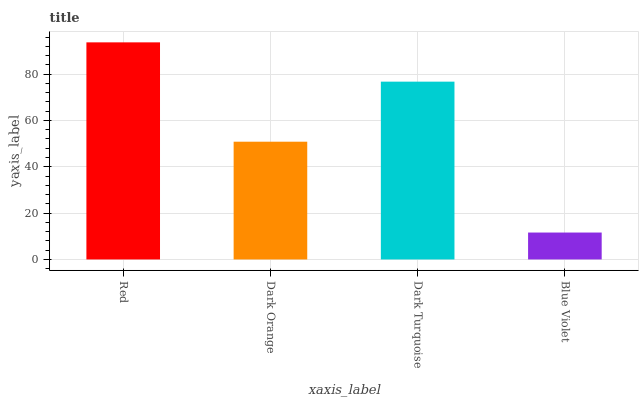Is Blue Violet the minimum?
Answer yes or no. Yes. Is Red the maximum?
Answer yes or no. Yes. Is Dark Orange the minimum?
Answer yes or no. No. Is Dark Orange the maximum?
Answer yes or no. No. Is Red greater than Dark Orange?
Answer yes or no. Yes. Is Dark Orange less than Red?
Answer yes or no. Yes. Is Dark Orange greater than Red?
Answer yes or no. No. Is Red less than Dark Orange?
Answer yes or no. No. Is Dark Turquoise the high median?
Answer yes or no. Yes. Is Dark Orange the low median?
Answer yes or no. Yes. Is Blue Violet the high median?
Answer yes or no. No. Is Dark Turquoise the low median?
Answer yes or no. No. 